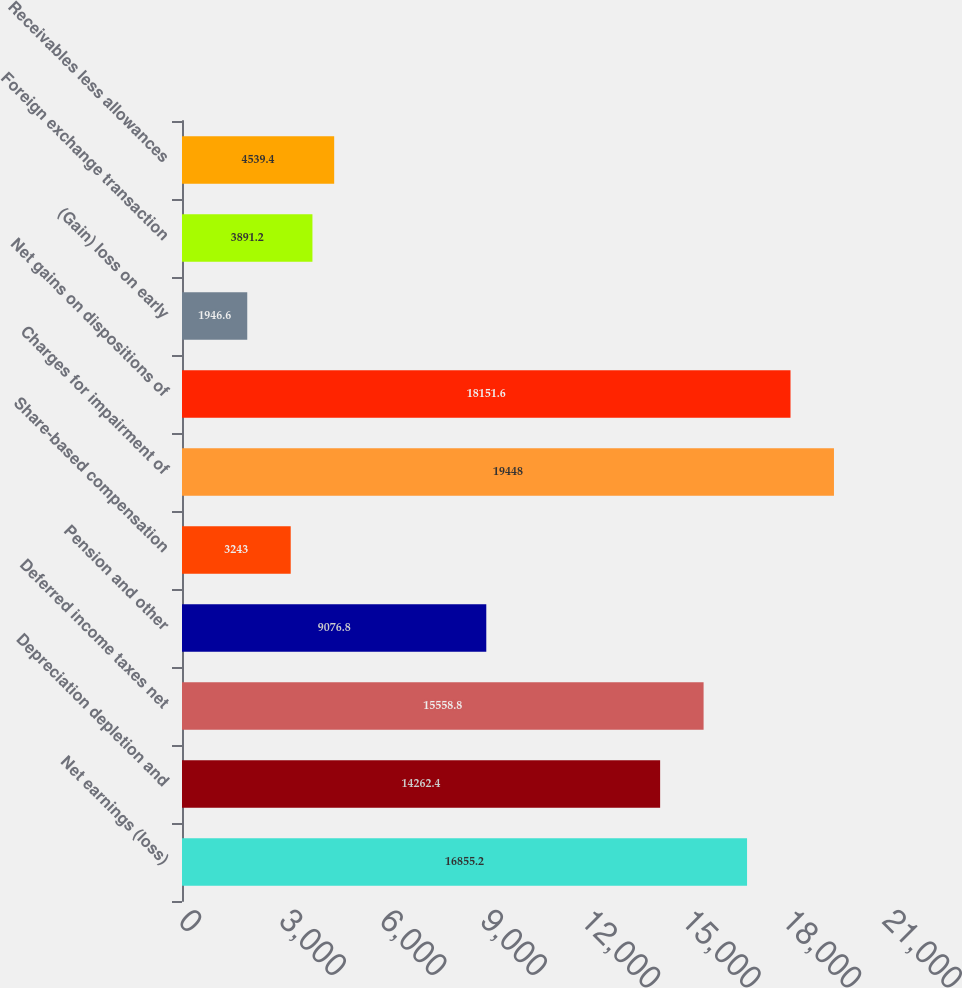<chart> <loc_0><loc_0><loc_500><loc_500><bar_chart><fcel>Net earnings (loss)<fcel>Depreciation depletion and<fcel>Deferred income taxes net<fcel>Pension and other<fcel>Share-based compensation<fcel>Charges for impairment of<fcel>Net gains on dispositions of<fcel>(Gain) loss on early<fcel>Foreign exchange transaction<fcel>Receivables less allowances<nl><fcel>16855.2<fcel>14262.4<fcel>15558.8<fcel>9076.8<fcel>3243<fcel>19448<fcel>18151.6<fcel>1946.6<fcel>3891.2<fcel>4539.4<nl></chart> 